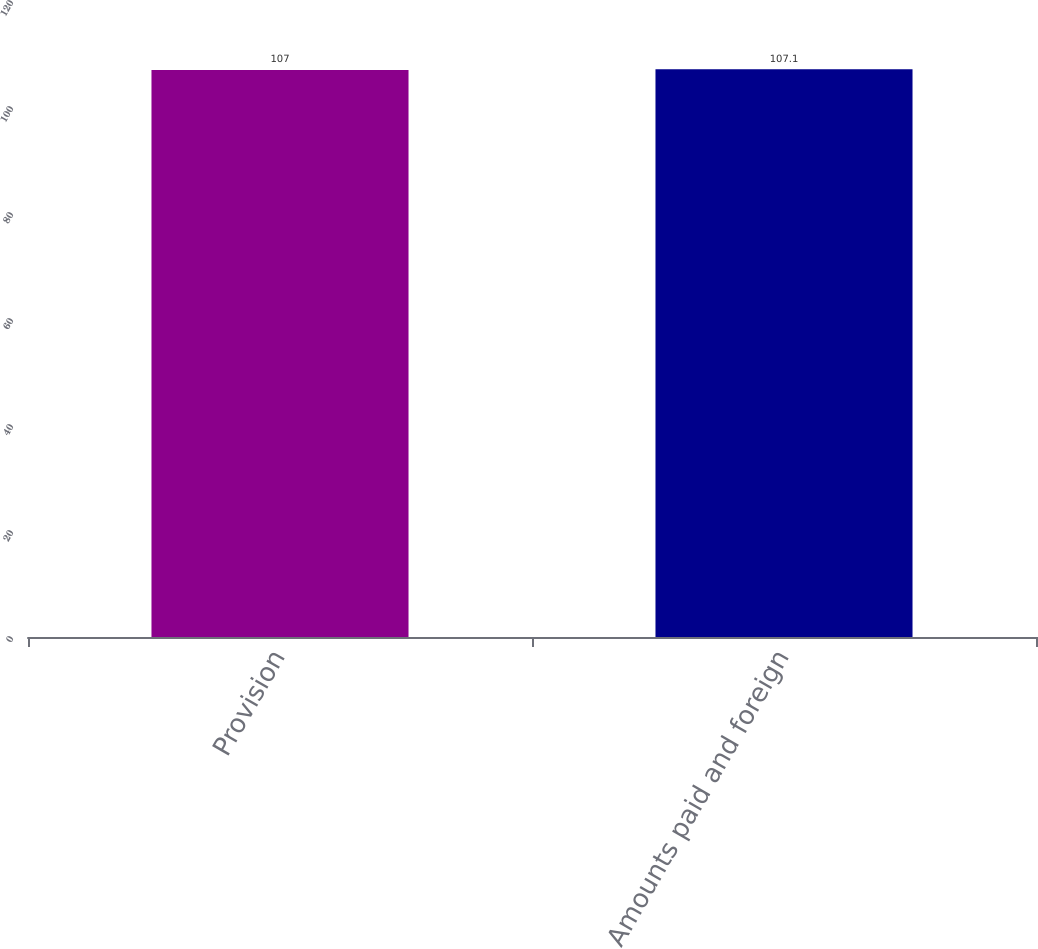Convert chart to OTSL. <chart><loc_0><loc_0><loc_500><loc_500><bar_chart><fcel>Provision<fcel>Amounts paid and foreign<nl><fcel>107<fcel>107.1<nl></chart> 